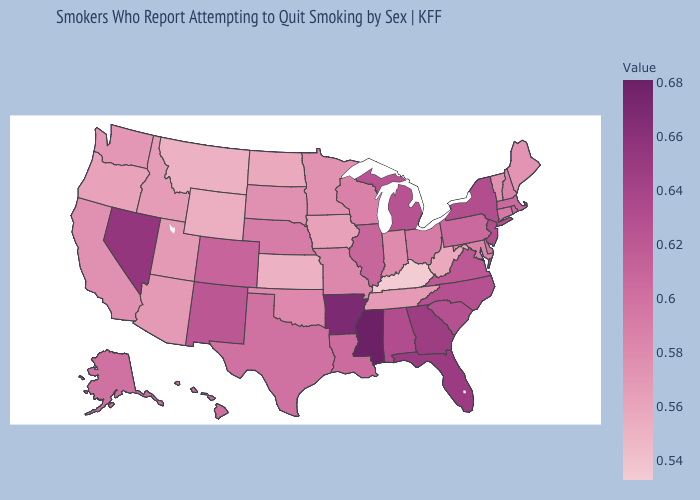Among the states that border Michigan , which have the highest value?
Short answer required. Ohio. Does Oklahoma have a higher value than Wyoming?
Concise answer only. Yes. Which states have the lowest value in the USA?
Give a very brief answer. Kentucky. Among the states that border Alabama , does Tennessee have the lowest value?
Answer briefly. Yes. Does Vermont have a lower value than Alaska?
Quick response, please. Yes. Does Kentucky have the lowest value in the USA?
Be succinct. Yes. Which states hav the highest value in the South?
Answer briefly. Mississippi. 